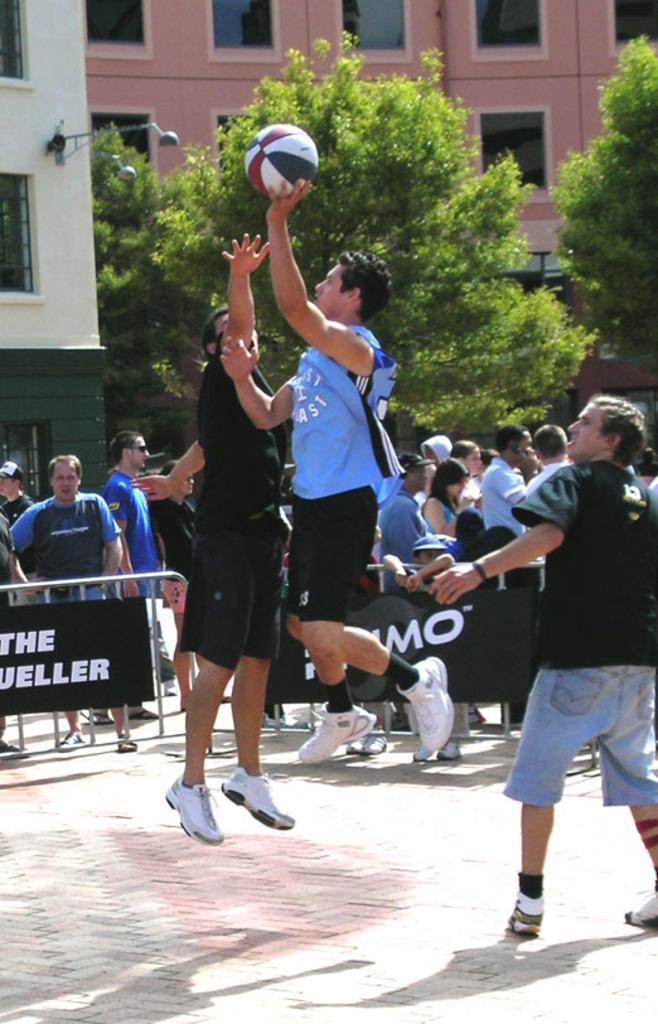Please provide a concise description of this image. In this picture I can see few people playing with the ball and I can see trees and buildings and I can see text on the fence and I can see few people standing and watching and few are walking and I can see few trees. 